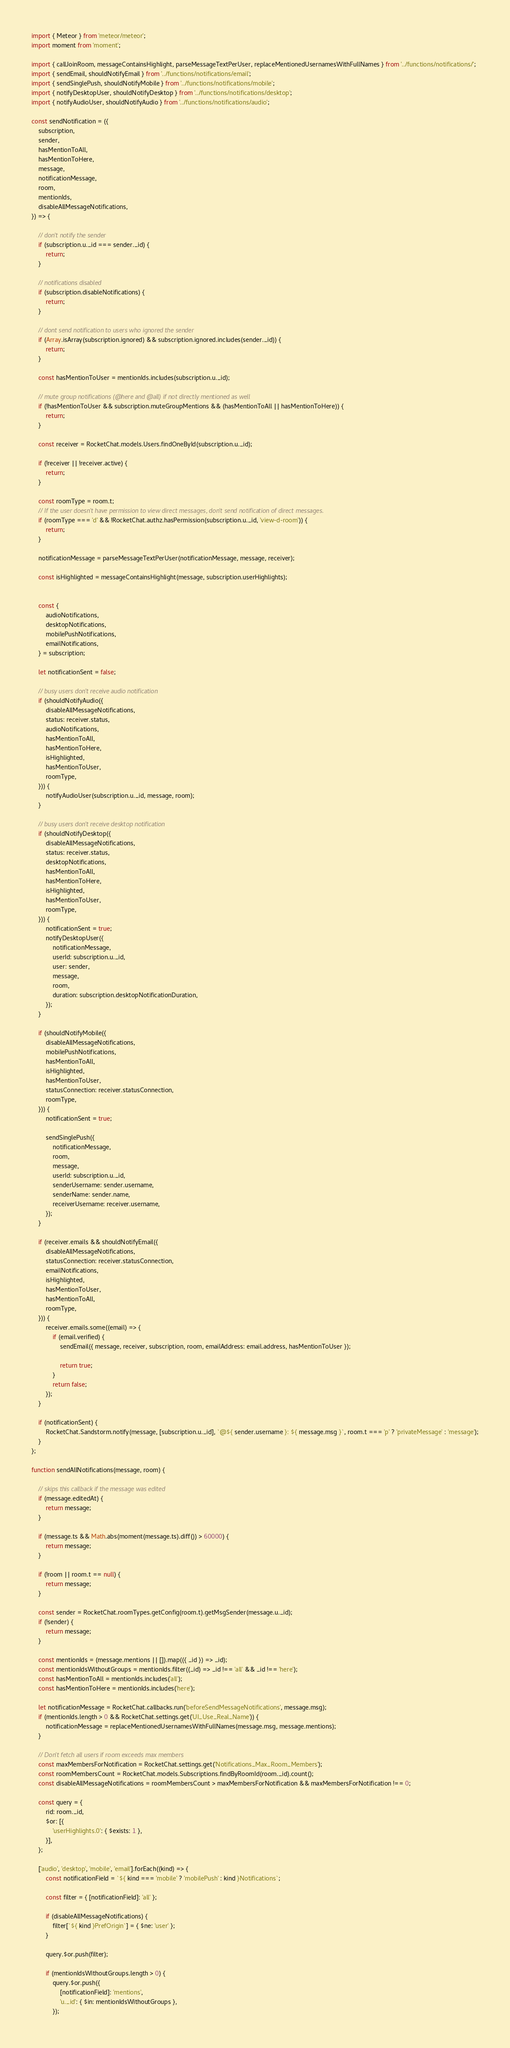Convert code to text. <code><loc_0><loc_0><loc_500><loc_500><_JavaScript_>import { Meteor } from 'meteor/meteor';
import moment from 'moment';

import { callJoinRoom, messageContainsHighlight, parseMessageTextPerUser, replaceMentionedUsernamesWithFullNames } from '../functions/notifications/';
import { sendEmail, shouldNotifyEmail } from '../functions/notifications/email';
import { sendSinglePush, shouldNotifyMobile } from '../functions/notifications/mobile';
import { notifyDesktopUser, shouldNotifyDesktop } from '../functions/notifications/desktop';
import { notifyAudioUser, shouldNotifyAudio } from '../functions/notifications/audio';

const sendNotification = ({
	subscription,
	sender,
	hasMentionToAll,
	hasMentionToHere,
	message,
	notificationMessage,
	room,
	mentionIds,
	disableAllMessageNotifications,
}) => {

	// don't notify the sender
	if (subscription.u._id === sender._id) {
		return;
	}

	// notifications disabled
	if (subscription.disableNotifications) {
		return;
	}

	// dont send notification to users who ignored the sender
	if (Array.isArray(subscription.ignored) && subscription.ignored.includes(sender._id)) {
		return;
	}

	const hasMentionToUser = mentionIds.includes(subscription.u._id);

	// mute group notifications (@here and @all) if not directly mentioned as well
	if (!hasMentionToUser && subscription.muteGroupMentions && (hasMentionToAll || hasMentionToHere)) {
		return;
	}

	const receiver = RocketChat.models.Users.findOneById(subscription.u._id);

	if (!receiver || !receiver.active) {
		return;
	}

	const roomType = room.t;
	// If the user doesn't have permission to view direct messages, don't send notification of direct messages.
	if (roomType === 'd' && !RocketChat.authz.hasPermission(subscription.u._id, 'view-d-room')) {
		return;
	}

	notificationMessage = parseMessageTextPerUser(notificationMessage, message, receiver);

	const isHighlighted = messageContainsHighlight(message, subscription.userHighlights);


	const {
		audioNotifications,
		desktopNotifications,
		mobilePushNotifications,
		emailNotifications,
	} = subscription;

	let notificationSent = false;

	// busy users don't receive audio notification
	if (shouldNotifyAudio({
		disableAllMessageNotifications,
		status: receiver.status,
		audioNotifications,
		hasMentionToAll,
		hasMentionToHere,
		isHighlighted,
		hasMentionToUser,
		roomType,
	})) {
		notifyAudioUser(subscription.u._id, message, room);
	}

	// busy users don't receive desktop notification
	if (shouldNotifyDesktop({
		disableAllMessageNotifications,
		status: receiver.status,
		desktopNotifications,
		hasMentionToAll,
		hasMentionToHere,
		isHighlighted,
		hasMentionToUser,
		roomType,
	})) {
		notificationSent = true;
		notifyDesktopUser({
			notificationMessage,
			userId: subscription.u._id,
			user: sender,
			message,
			room,
			duration: subscription.desktopNotificationDuration,
		});
	}

	if (shouldNotifyMobile({
		disableAllMessageNotifications,
		mobilePushNotifications,
		hasMentionToAll,
		isHighlighted,
		hasMentionToUser,
		statusConnection: receiver.statusConnection,
		roomType,
	})) {
		notificationSent = true;

		sendSinglePush({
			notificationMessage,
			room,
			message,
			userId: subscription.u._id,
			senderUsername: sender.username,
			senderName: sender.name,
			receiverUsername: receiver.username,
		});
	}

	if (receiver.emails && shouldNotifyEmail({
		disableAllMessageNotifications,
		statusConnection: receiver.statusConnection,
		emailNotifications,
		isHighlighted,
		hasMentionToUser,
		hasMentionToAll,
		roomType,
	})) {
		receiver.emails.some((email) => {
			if (email.verified) {
				sendEmail({ message, receiver, subscription, room, emailAddress: email.address, hasMentionToUser });

				return true;
			}
			return false;
		});
	}

	if (notificationSent) {
		RocketChat.Sandstorm.notify(message, [subscription.u._id], `@${ sender.username }: ${ message.msg }`, room.t === 'p' ? 'privateMessage' : 'message');
	}
};

function sendAllNotifications(message, room) {

	// skips this callback if the message was edited
	if (message.editedAt) {
		return message;
	}

	if (message.ts && Math.abs(moment(message.ts).diff()) > 60000) {
		return message;
	}

	if (!room || room.t == null) {
		return message;
	}

	const sender = RocketChat.roomTypes.getConfig(room.t).getMsgSender(message.u._id);
	if (!sender) {
		return message;
	}

	const mentionIds = (message.mentions || []).map(({ _id }) => _id);
	const mentionIdsWithoutGroups = mentionIds.filter((_id) => _id !== 'all' && _id !== 'here');
	const hasMentionToAll = mentionIds.includes('all');
	const hasMentionToHere = mentionIds.includes('here');

	let notificationMessage = RocketChat.callbacks.run('beforeSendMessageNotifications', message.msg);
	if (mentionIds.length > 0 && RocketChat.settings.get('UI_Use_Real_Name')) {
		notificationMessage = replaceMentionedUsernamesWithFullNames(message.msg, message.mentions);
	}

	// Don't fetch all users if room exceeds max members
	const maxMembersForNotification = RocketChat.settings.get('Notifications_Max_Room_Members');
	const roomMembersCount = RocketChat.models.Subscriptions.findByRoomId(room._id).count();
	const disableAllMessageNotifications = roomMembersCount > maxMembersForNotification && maxMembersForNotification !== 0;

	const query = {
		rid: room._id,
		$or: [{
			'userHighlights.0': { $exists: 1 },
		}],
	};

	['audio', 'desktop', 'mobile', 'email'].forEach((kind) => {
		const notificationField = `${ kind === 'mobile' ? 'mobilePush' : kind }Notifications`;

		const filter = { [notificationField]: 'all' };

		if (disableAllMessageNotifications) {
			filter[`${ kind }PrefOrigin`] = { $ne: 'user' };
		}

		query.$or.push(filter);

		if (mentionIdsWithoutGroups.length > 0) {
			query.$or.push({
				[notificationField]: 'mentions',
				'u._id': { $in: mentionIdsWithoutGroups },
			});</code> 